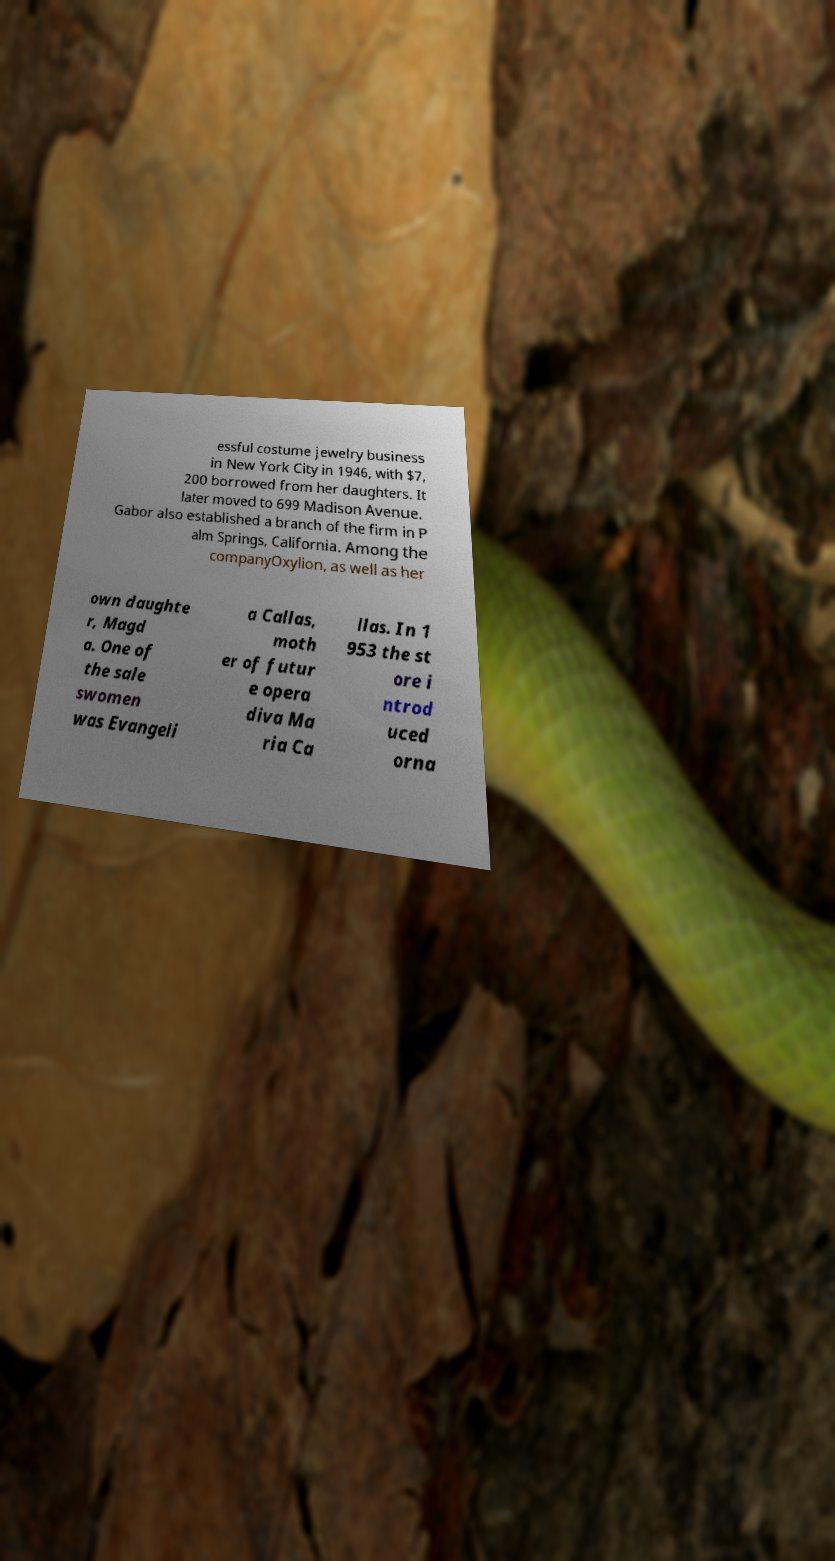Please identify and transcribe the text found in this image. essful costume jewelry business in New York City in 1946, with $7, 200 borrowed from her daughters. It later moved to 699 Madison Avenue. Gabor also established a branch of the firm in P alm Springs, California. Among the companyOxylion, as well as her own daughte r, Magd a. One of the sale swomen was Evangeli a Callas, moth er of futur e opera diva Ma ria Ca llas. In 1 953 the st ore i ntrod uced orna 